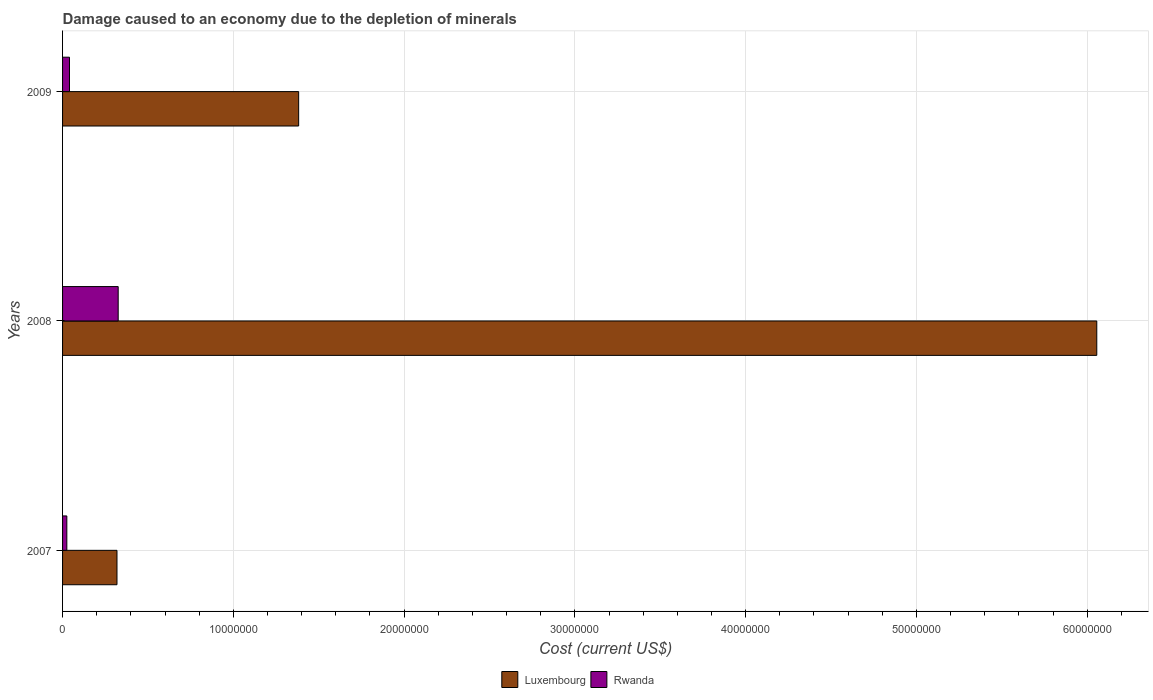How many different coloured bars are there?
Make the answer very short. 2. How many bars are there on the 3rd tick from the top?
Make the answer very short. 2. What is the cost of damage caused due to the depletion of minerals in Luxembourg in 2009?
Ensure brevity in your answer.  1.38e+07. Across all years, what is the maximum cost of damage caused due to the depletion of minerals in Rwanda?
Your response must be concise. 3.26e+06. Across all years, what is the minimum cost of damage caused due to the depletion of minerals in Luxembourg?
Keep it short and to the point. 3.19e+06. In which year was the cost of damage caused due to the depletion of minerals in Luxembourg minimum?
Your answer should be compact. 2007. What is the total cost of damage caused due to the depletion of minerals in Luxembourg in the graph?
Offer a terse response. 7.76e+07. What is the difference between the cost of damage caused due to the depletion of minerals in Rwanda in 2008 and that in 2009?
Provide a succinct answer. 2.85e+06. What is the difference between the cost of damage caused due to the depletion of minerals in Rwanda in 2008 and the cost of damage caused due to the depletion of minerals in Luxembourg in 2007?
Keep it short and to the point. 7.08e+04. What is the average cost of damage caused due to the depletion of minerals in Rwanda per year?
Provide a succinct answer. 1.30e+06. In the year 2008, what is the difference between the cost of damage caused due to the depletion of minerals in Luxembourg and cost of damage caused due to the depletion of minerals in Rwanda?
Give a very brief answer. 5.73e+07. In how many years, is the cost of damage caused due to the depletion of minerals in Rwanda greater than 54000000 US$?
Provide a short and direct response. 0. What is the ratio of the cost of damage caused due to the depletion of minerals in Rwanda in 2007 to that in 2009?
Provide a short and direct response. 0.62. Is the cost of damage caused due to the depletion of minerals in Luxembourg in 2007 less than that in 2008?
Provide a succinct answer. Yes. What is the difference between the highest and the second highest cost of damage caused due to the depletion of minerals in Rwanda?
Make the answer very short. 2.85e+06. What is the difference between the highest and the lowest cost of damage caused due to the depletion of minerals in Rwanda?
Make the answer very short. 3.01e+06. What does the 2nd bar from the top in 2008 represents?
Offer a terse response. Luxembourg. What does the 2nd bar from the bottom in 2008 represents?
Give a very brief answer. Rwanda. Does the graph contain grids?
Your answer should be very brief. Yes. Where does the legend appear in the graph?
Offer a very short reply. Bottom center. How are the legend labels stacked?
Keep it short and to the point. Horizontal. What is the title of the graph?
Keep it short and to the point. Damage caused to an economy due to the depletion of minerals. Does "Zimbabwe" appear as one of the legend labels in the graph?
Offer a terse response. No. What is the label or title of the X-axis?
Ensure brevity in your answer.  Cost (current US$). What is the Cost (current US$) of Luxembourg in 2007?
Offer a terse response. 3.19e+06. What is the Cost (current US$) of Rwanda in 2007?
Your answer should be very brief. 2.50e+05. What is the Cost (current US$) of Luxembourg in 2008?
Your response must be concise. 6.06e+07. What is the Cost (current US$) in Rwanda in 2008?
Provide a short and direct response. 3.26e+06. What is the Cost (current US$) of Luxembourg in 2009?
Offer a terse response. 1.38e+07. What is the Cost (current US$) of Rwanda in 2009?
Give a very brief answer. 4.06e+05. Across all years, what is the maximum Cost (current US$) of Luxembourg?
Your response must be concise. 6.06e+07. Across all years, what is the maximum Cost (current US$) of Rwanda?
Make the answer very short. 3.26e+06. Across all years, what is the minimum Cost (current US$) in Luxembourg?
Give a very brief answer. 3.19e+06. Across all years, what is the minimum Cost (current US$) of Rwanda?
Offer a very short reply. 2.50e+05. What is the total Cost (current US$) of Luxembourg in the graph?
Give a very brief answer. 7.76e+07. What is the total Cost (current US$) in Rwanda in the graph?
Make the answer very short. 3.91e+06. What is the difference between the Cost (current US$) in Luxembourg in 2007 and that in 2008?
Your answer should be compact. -5.74e+07. What is the difference between the Cost (current US$) of Rwanda in 2007 and that in 2008?
Provide a succinct answer. -3.01e+06. What is the difference between the Cost (current US$) in Luxembourg in 2007 and that in 2009?
Your answer should be compact. -1.06e+07. What is the difference between the Cost (current US$) of Rwanda in 2007 and that in 2009?
Your answer should be compact. -1.56e+05. What is the difference between the Cost (current US$) of Luxembourg in 2008 and that in 2009?
Offer a very short reply. 4.67e+07. What is the difference between the Cost (current US$) in Rwanda in 2008 and that in 2009?
Offer a very short reply. 2.85e+06. What is the difference between the Cost (current US$) in Luxembourg in 2007 and the Cost (current US$) in Rwanda in 2008?
Provide a succinct answer. -7.08e+04. What is the difference between the Cost (current US$) of Luxembourg in 2007 and the Cost (current US$) of Rwanda in 2009?
Offer a very short reply. 2.78e+06. What is the difference between the Cost (current US$) of Luxembourg in 2008 and the Cost (current US$) of Rwanda in 2009?
Offer a very short reply. 6.02e+07. What is the average Cost (current US$) in Luxembourg per year?
Provide a short and direct response. 2.59e+07. What is the average Cost (current US$) of Rwanda per year?
Offer a terse response. 1.30e+06. In the year 2007, what is the difference between the Cost (current US$) in Luxembourg and Cost (current US$) in Rwanda?
Your answer should be very brief. 2.94e+06. In the year 2008, what is the difference between the Cost (current US$) of Luxembourg and Cost (current US$) of Rwanda?
Keep it short and to the point. 5.73e+07. In the year 2009, what is the difference between the Cost (current US$) in Luxembourg and Cost (current US$) in Rwanda?
Make the answer very short. 1.34e+07. What is the ratio of the Cost (current US$) of Luxembourg in 2007 to that in 2008?
Your answer should be compact. 0.05. What is the ratio of the Cost (current US$) in Rwanda in 2007 to that in 2008?
Offer a very short reply. 0.08. What is the ratio of the Cost (current US$) of Luxembourg in 2007 to that in 2009?
Your response must be concise. 0.23. What is the ratio of the Cost (current US$) in Rwanda in 2007 to that in 2009?
Provide a succinct answer. 0.62. What is the ratio of the Cost (current US$) of Luxembourg in 2008 to that in 2009?
Offer a terse response. 4.38. What is the ratio of the Cost (current US$) in Rwanda in 2008 to that in 2009?
Give a very brief answer. 8.03. What is the difference between the highest and the second highest Cost (current US$) in Luxembourg?
Offer a terse response. 4.67e+07. What is the difference between the highest and the second highest Cost (current US$) in Rwanda?
Your answer should be very brief. 2.85e+06. What is the difference between the highest and the lowest Cost (current US$) of Luxembourg?
Provide a short and direct response. 5.74e+07. What is the difference between the highest and the lowest Cost (current US$) in Rwanda?
Offer a very short reply. 3.01e+06. 